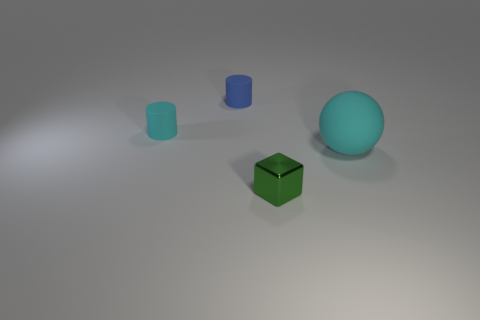How many other things are there of the same color as the tiny block?
Ensure brevity in your answer.  0. There is a big rubber object; is it the same shape as the cyan object left of the green metal block?
Make the answer very short. No. What number of things are tiny cyan matte cylinders or cylinders that are right of the tiny cyan thing?
Your answer should be very brief. 2. There is another thing that is the same shape as the small blue thing; what is its material?
Your answer should be compact. Rubber. Do the object that is left of the blue cylinder and the large cyan thing have the same shape?
Ensure brevity in your answer.  No. Are there any other things that are the same size as the blue matte cylinder?
Make the answer very short. Yes. Is the number of cylinders that are to the right of the shiny object less than the number of green objects in front of the cyan cylinder?
Keep it short and to the point. Yes. How many other objects are there of the same shape as the big rubber object?
Give a very brief answer. 0. There is a cyan rubber object that is to the left of the cyan object that is right of the thing that is in front of the big rubber thing; how big is it?
Your answer should be compact. Small. How many yellow things are tiny shiny cubes or tiny objects?
Your answer should be very brief. 0. 